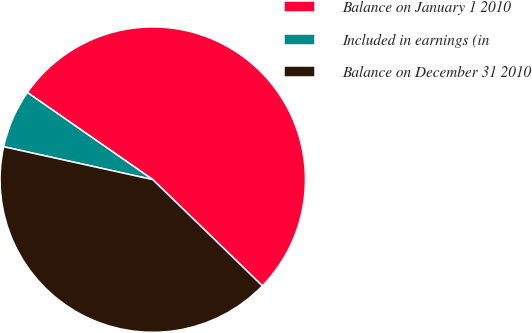<chart> <loc_0><loc_0><loc_500><loc_500><pie_chart><fcel>Balance on January 1 2010<fcel>Included in earnings (in<fcel>Balance on December 31 2010<nl><fcel>52.59%<fcel>6.21%<fcel>41.2%<nl></chart> 